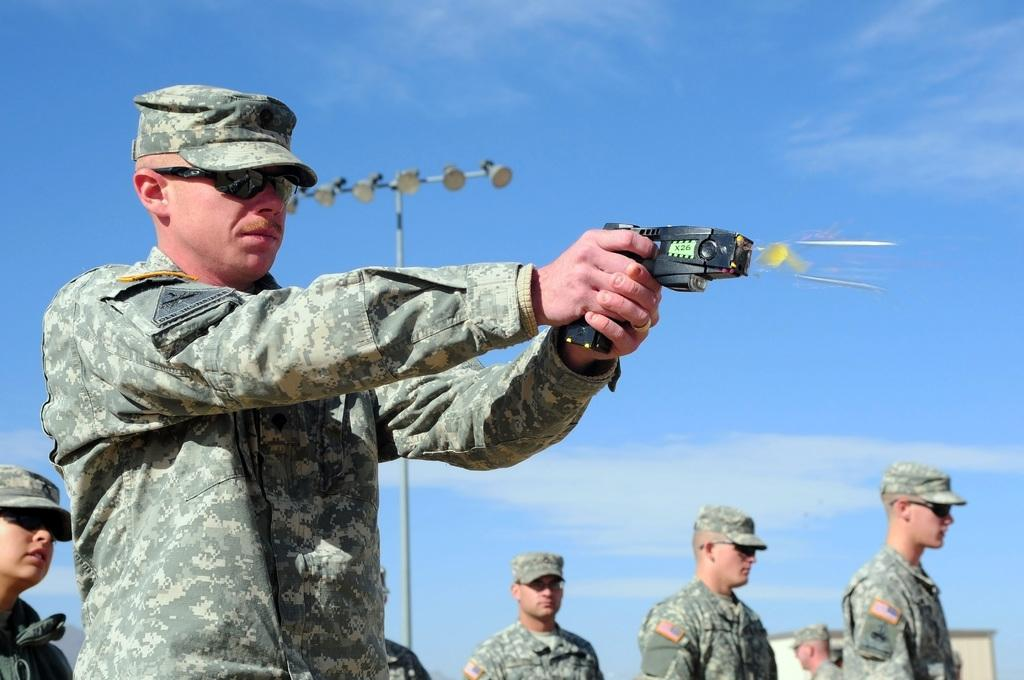How many people are in the image? There are people in the image, but the exact number is not specified. What is one person doing in the image? One person is firing a gun in the image. What can be seen attached to the pole in the image? There is a pole with lights in the image. What type of structure is at the bottom of the image? There is a house at the bottom of the image. What type of cheese is being used to build the plane in the image? There is no plane or cheese present in the image. How many bits are visible on the house in the image? There are no bits visible on the house in the image. 